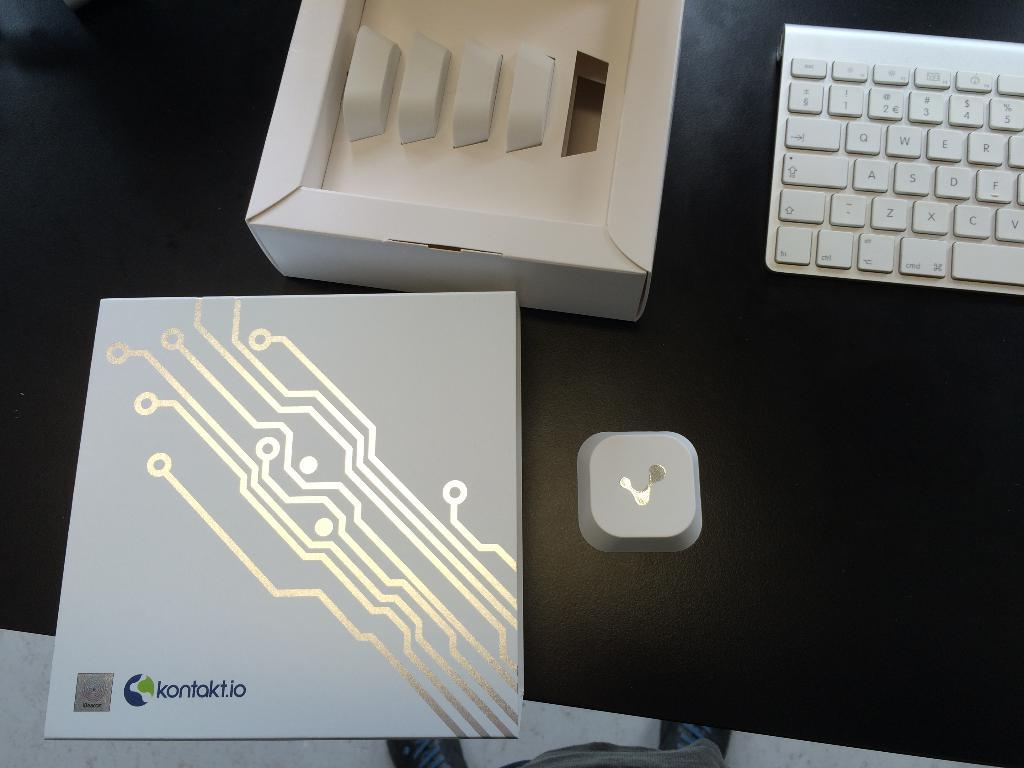<image>
Give a short and clear explanation of the subsequent image. A Kontakt.io product sits on a table near a white keyboard. 